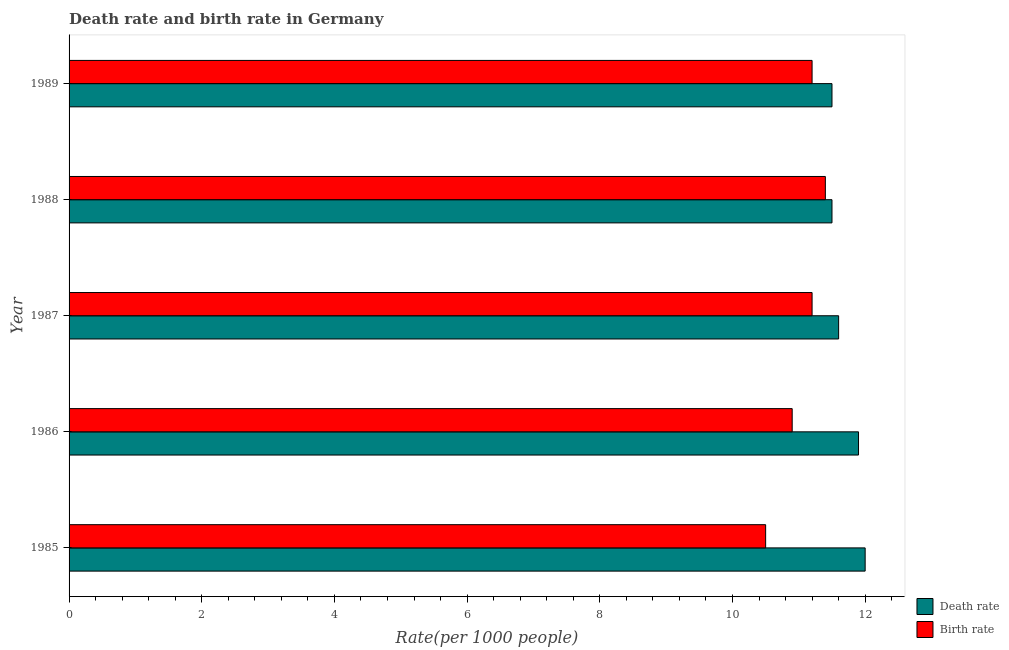How many different coloured bars are there?
Provide a succinct answer. 2. How many groups of bars are there?
Provide a short and direct response. 5. Are the number of bars per tick equal to the number of legend labels?
Provide a succinct answer. Yes. Are the number of bars on each tick of the Y-axis equal?
Offer a terse response. Yes. How many bars are there on the 1st tick from the top?
Make the answer very short. 2. What is the label of the 5th group of bars from the top?
Provide a succinct answer. 1985. What is the death rate in 1989?
Give a very brief answer. 11.5. Across all years, what is the minimum birth rate?
Keep it short and to the point. 10.5. In which year was the death rate minimum?
Provide a succinct answer. 1988. What is the total death rate in the graph?
Keep it short and to the point. 58.5. What is the difference between the death rate in 1985 and the birth rate in 1987?
Provide a succinct answer. 0.8. What is the average death rate per year?
Keep it short and to the point. 11.7. In how many years, is the birth rate greater than 0.4 ?
Ensure brevity in your answer.  5. What is the ratio of the birth rate in 1985 to that in 1987?
Give a very brief answer. 0.94. What is the difference between the highest and the second highest death rate?
Offer a very short reply. 0.1. What is the difference between the highest and the lowest birth rate?
Keep it short and to the point. 0.9. In how many years, is the birth rate greater than the average birth rate taken over all years?
Provide a short and direct response. 3. What does the 1st bar from the top in 1985 represents?
Offer a very short reply. Birth rate. What does the 1st bar from the bottom in 1986 represents?
Ensure brevity in your answer.  Death rate. How many legend labels are there?
Give a very brief answer. 2. What is the title of the graph?
Give a very brief answer. Death rate and birth rate in Germany. Does "Forest" appear as one of the legend labels in the graph?
Offer a terse response. No. What is the label or title of the X-axis?
Provide a short and direct response. Rate(per 1000 people). What is the label or title of the Y-axis?
Give a very brief answer. Year. What is the Rate(per 1000 people) of Death rate in 1985?
Your response must be concise. 12. What is the Rate(per 1000 people) of Birth rate in 1985?
Make the answer very short. 10.5. What is the Rate(per 1000 people) of Death rate in 1986?
Ensure brevity in your answer.  11.9. What is the Rate(per 1000 people) in Death rate in 1987?
Provide a short and direct response. 11.6. What is the Rate(per 1000 people) in Birth rate in 1987?
Your answer should be compact. 11.2. What is the Rate(per 1000 people) in Death rate in 1988?
Your answer should be compact. 11.5. What is the Rate(per 1000 people) in Birth rate in 1988?
Your response must be concise. 11.4. What is the Rate(per 1000 people) in Birth rate in 1989?
Your answer should be very brief. 11.2. Across all years, what is the maximum Rate(per 1000 people) in Death rate?
Offer a very short reply. 12. Across all years, what is the maximum Rate(per 1000 people) in Birth rate?
Offer a very short reply. 11.4. What is the total Rate(per 1000 people) in Death rate in the graph?
Keep it short and to the point. 58.5. What is the total Rate(per 1000 people) of Birth rate in the graph?
Provide a succinct answer. 55.2. What is the difference between the Rate(per 1000 people) of Death rate in 1985 and that in 1986?
Give a very brief answer. 0.1. What is the difference between the Rate(per 1000 people) in Birth rate in 1985 and that in 1986?
Keep it short and to the point. -0.4. What is the difference between the Rate(per 1000 people) in Death rate in 1985 and that in 1987?
Provide a succinct answer. 0.4. What is the difference between the Rate(per 1000 people) in Birth rate in 1985 and that in 1987?
Offer a very short reply. -0.7. What is the difference between the Rate(per 1000 people) of Death rate in 1985 and that in 1988?
Your answer should be compact. 0.5. What is the difference between the Rate(per 1000 people) in Death rate in 1985 and that in 1989?
Your answer should be very brief. 0.5. What is the difference between the Rate(per 1000 people) in Death rate in 1986 and that in 1987?
Ensure brevity in your answer.  0.3. What is the difference between the Rate(per 1000 people) of Birth rate in 1986 and that in 1987?
Provide a short and direct response. -0.3. What is the difference between the Rate(per 1000 people) of Death rate in 1986 and that in 1988?
Provide a succinct answer. 0.4. What is the difference between the Rate(per 1000 people) in Death rate in 1986 and that in 1989?
Keep it short and to the point. 0.4. What is the difference between the Rate(per 1000 people) of Death rate in 1987 and that in 1988?
Offer a very short reply. 0.1. What is the difference between the Rate(per 1000 people) of Death rate in 1988 and that in 1989?
Your response must be concise. 0. What is the difference between the Rate(per 1000 people) of Birth rate in 1988 and that in 1989?
Offer a very short reply. 0.2. What is the difference between the Rate(per 1000 people) of Death rate in 1985 and the Rate(per 1000 people) of Birth rate in 1988?
Make the answer very short. 0.6. What is the difference between the Rate(per 1000 people) of Death rate in 1985 and the Rate(per 1000 people) of Birth rate in 1989?
Your response must be concise. 0.8. What is the difference between the Rate(per 1000 people) in Death rate in 1986 and the Rate(per 1000 people) in Birth rate in 1987?
Make the answer very short. 0.7. What is the difference between the Rate(per 1000 people) in Death rate in 1986 and the Rate(per 1000 people) in Birth rate in 1988?
Ensure brevity in your answer.  0.5. What is the difference between the Rate(per 1000 people) of Death rate in 1986 and the Rate(per 1000 people) of Birth rate in 1989?
Provide a succinct answer. 0.7. What is the difference between the Rate(per 1000 people) of Death rate in 1987 and the Rate(per 1000 people) of Birth rate in 1988?
Keep it short and to the point. 0.2. What is the average Rate(per 1000 people) in Death rate per year?
Your response must be concise. 11.7. What is the average Rate(per 1000 people) in Birth rate per year?
Provide a short and direct response. 11.04. In the year 1986, what is the difference between the Rate(per 1000 people) in Death rate and Rate(per 1000 people) in Birth rate?
Your answer should be compact. 1. In the year 1987, what is the difference between the Rate(per 1000 people) in Death rate and Rate(per 1000 people) in Birth rate?
Your response must be concise. 0.4. In the year 1988, what is the difference between the Rate(per 1000 people) in Death rate and Rate(per 1000 people) in Birth rate?
Provide a succinct answer. 0.1. In the year 1989, what is the difference between the Rate(per 1000 people) of Death rate and Rate(per 1000 people) of Birth rate?
Your response must be concise. 0.3. What is the ratio of the Rate(per 1000 people) of Death rate in 1985 to that in 1986?
Provide a succinct answer. 1.01. What is the ratio of the Rate(per 1000 people) in Birth rate in 1985 to that in 1986?
Ensure brevity in your answer.  0.96. What is the ratio of the Rate(per 1000 people) in Death rate in 1985 to that in 1987?
Make the answer very short. 1.03. What is the ratio of the Rate(per 1000 people) of Death rate in 1985 to that in 1988?
Offer a terse response. 1.04. What is the ratio of the Rate(per 1000 people) of Birth rate in 1985 to that in 1988?
Ensure brevity in your answer.  0.92. What is the ratio of the Rate(per 1000 people) of Death rate in 1985 to that in 1989?
Give a very brief answer. 1.04. What is the ratio of the Rate(per 1000 people) of Birth rate in 1985 to that in 1989?
Provide a succinct answer. 0.94. What is the ratio of the Rate(per 1000 people) in Death rate in 1986 to that in 1987?
Provide a succinct answer. 1.03. What is the ratio of the Rate(per 1000 people) of Birth rate in 1986 to that in 1987?
Your answer should be compact. 0.97. What is the ratio of the Rate(per 1000 people) of Death rate in 1986 to that in 1988?
Provide a succinct answer. 1.03. What is the ratio of the Rate(per 1000 people) of Birth rate in 1986 to that in 1988?
Provide a short and direct response. 0.96. What is the ratio of the Rate(per 1000 people) in Death rate in 1986 to that in 1989?
Your answer should be very brief. 1.03. What is the ratio of the Rate(per 1000 people) in Birth rate in 1986 to that in 1989?
Offer a very short reply. 0.97. What is the ratio of the Rate(per 1000 people) of Death rate in 1987 to that in 1988?
Make the answer very short. 1.01. What is the ratio of the Rate(per 1000 people) in Birth rate in 1987 to that in 1988?
Ensure brevity in your answer.  0.98. What is the ratio of the Rate(per 1000 people) in Death rate in 1987 to that in 1989?
Offer a terse response. 1.01. What is the ratio of the Rate(per 1000 people) in Birth rate in 1988 to that in 1989?
Your answer should be compact. 1.02. What is the difference between the highest and the second highest Rate(per 1000 people) of Death rate?
Give a very brief answer. 0.1. What is the difference between the highest and the lowest Rate(per 1000 people) of Death rate?
Offer a very short reply. 0.5. What is the difference between the highest and the lowest Rate(per 1000 people) in Birth rate?
Keep it short and to the point. 0.9. 